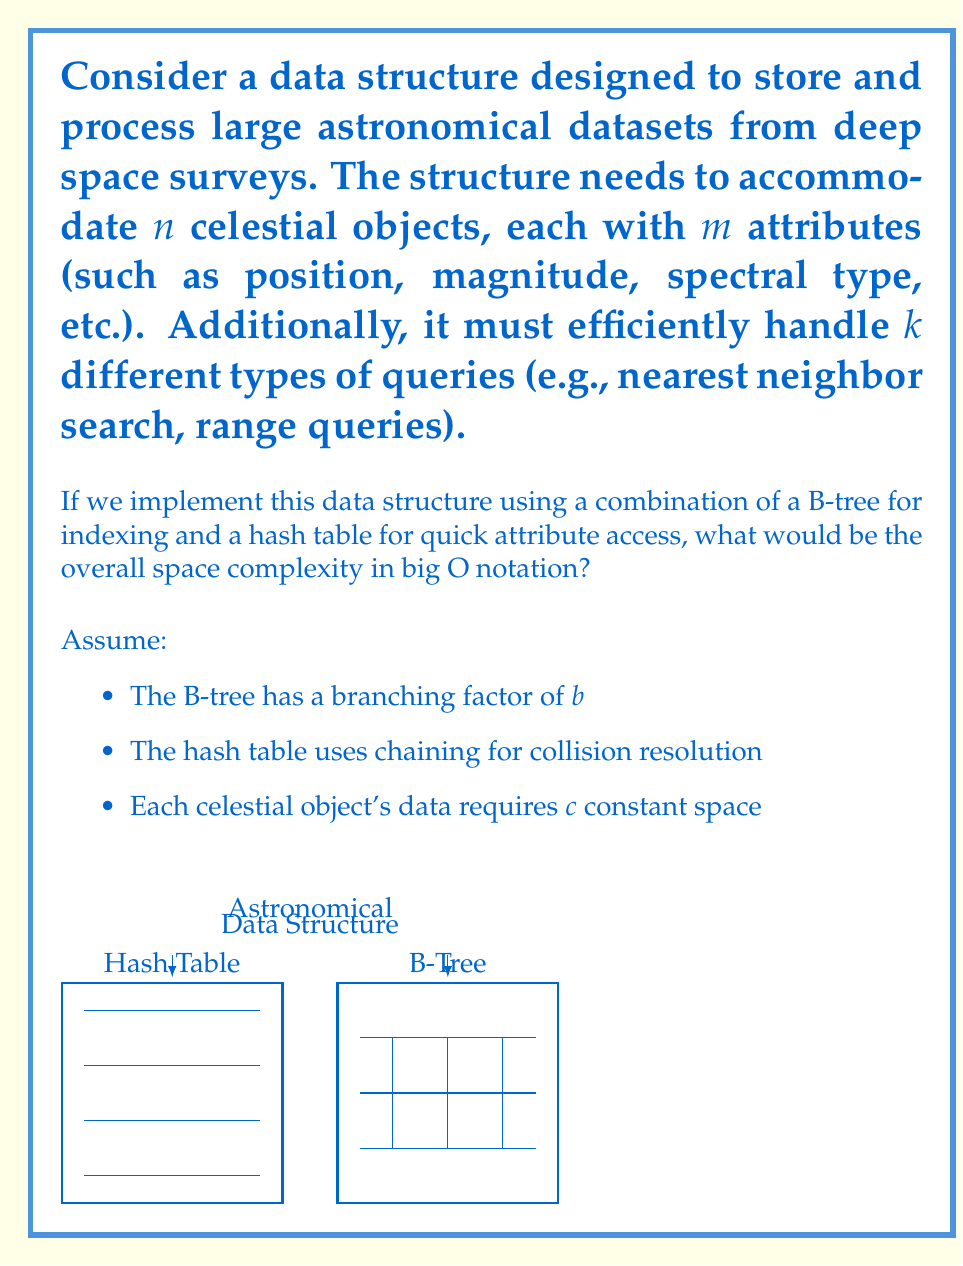Can you solve this math problem? Let's break down the space complexity analysis step by step:

1. B-tree space complexity:
   - A B-tree with $n$ elements and branching factor $b$ has a height of $O(\log_b n)$
   - Each node can store up to $b-1$ keys and $b$ pointers
   - The total number of nodes is $O(n/b)$
   - Space required for the B-tree: $O((n/b) \cdot b) = O(n)$

2. Hash table space complexity:
   - We need to store $n$ objects, each with $m$ attributes
   - The hash table size is typically chosen to be proportional to $n$
   - Space required for the hash table: $O(n \cdot m)$

3. Storage for celestial objects:
   - Each object requires $c$ constant space
   - Total space for objects: $O(n \cdot c) = O(n)$

4. Additional space for query handling:
   - We need to accommodate $k$ different types of queries
   - This might require additional data structures or indices
   - Let's assume this takes $O(k \cdot n)$ space in the worst case

5. Combining all components:
   - Total space = B-tree + Hash table + Object storage + Query handling
   - $O(n) + O(n \cdot m) + O(n) + O(k \cdot n)$
   - $= O(n + n \cdot m + n + k \cdot n)$
   - $= O(n \cdot (m + k + 1))$

6. Simplifying:
   - Since $m$ and $k$ are independent of $n$, we can treat them as constants
   - The final space complexity becomes $O(n)$

Therefore, the overall space complexity of the data structure is $O(n)$, where $n$ is the number of celestial objects stored.
Answer: $O(n)$ 